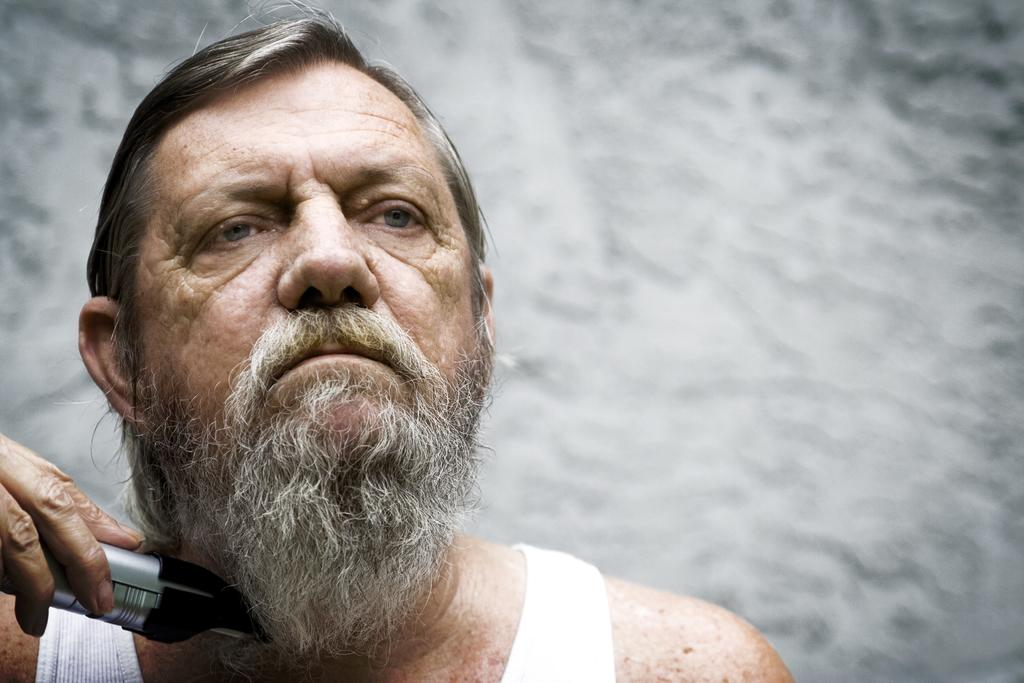What is the main subject of the image? There is a person in the image. What is the person doing in the image? The person is holding an object. Can you describe the background of the image? The background of the image is blurred. What type of fruit can be seen growing on the person's head in the image? There is no fruit visible on the person's head in the image. 